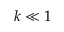<formula> <loc_0><loc_0><loc_500><loc_500>k \ll 1</formula> 